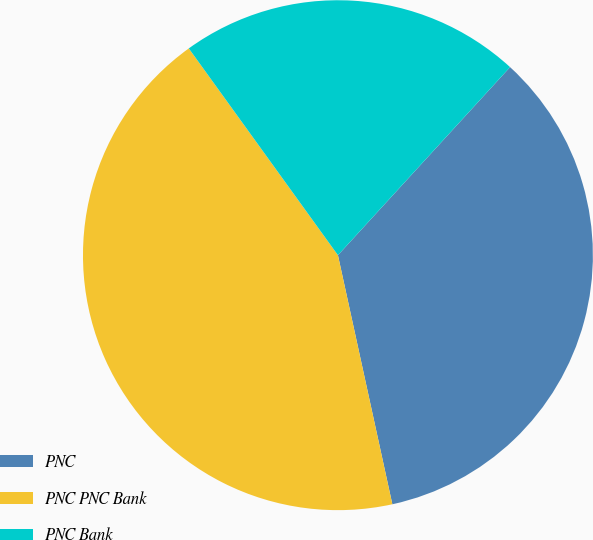<chart> <loc_0><loc_0><loc_500><loc_500><pie_chart><fcel>PNC<fcel>PNC PNC Bank<fcel>PNC Bank<nl><fcel>34.78%<fcel>43.48%<fcel>21.74%<nl></chart> 